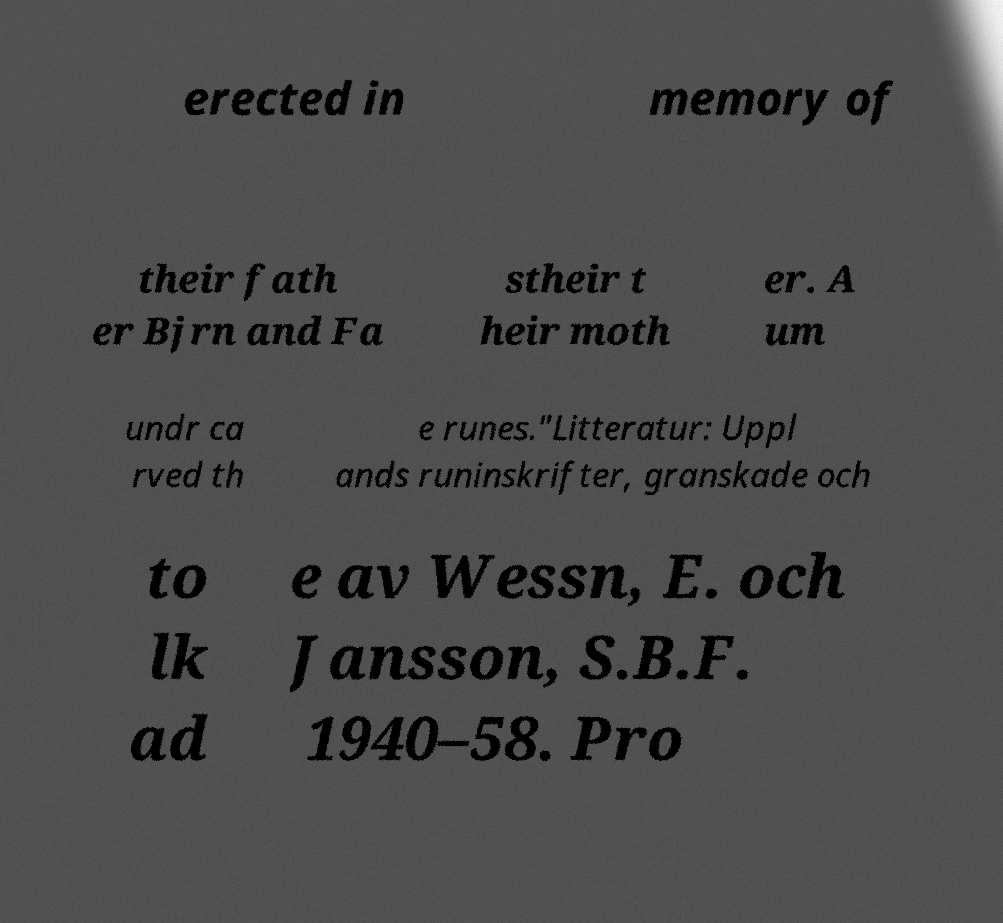There's text embedded in this image that I need extracted. Can you transcribe it verbatim? erected in memory of their fath er Bjrn and Fa stheir t heir moth er. A um undr ca rved th e runes."Litteratur: Uppl ands runinskrifter, granskade och to lk ad e av Wessn, E. och Jansson, S.B.F. 1940–58. Pro 